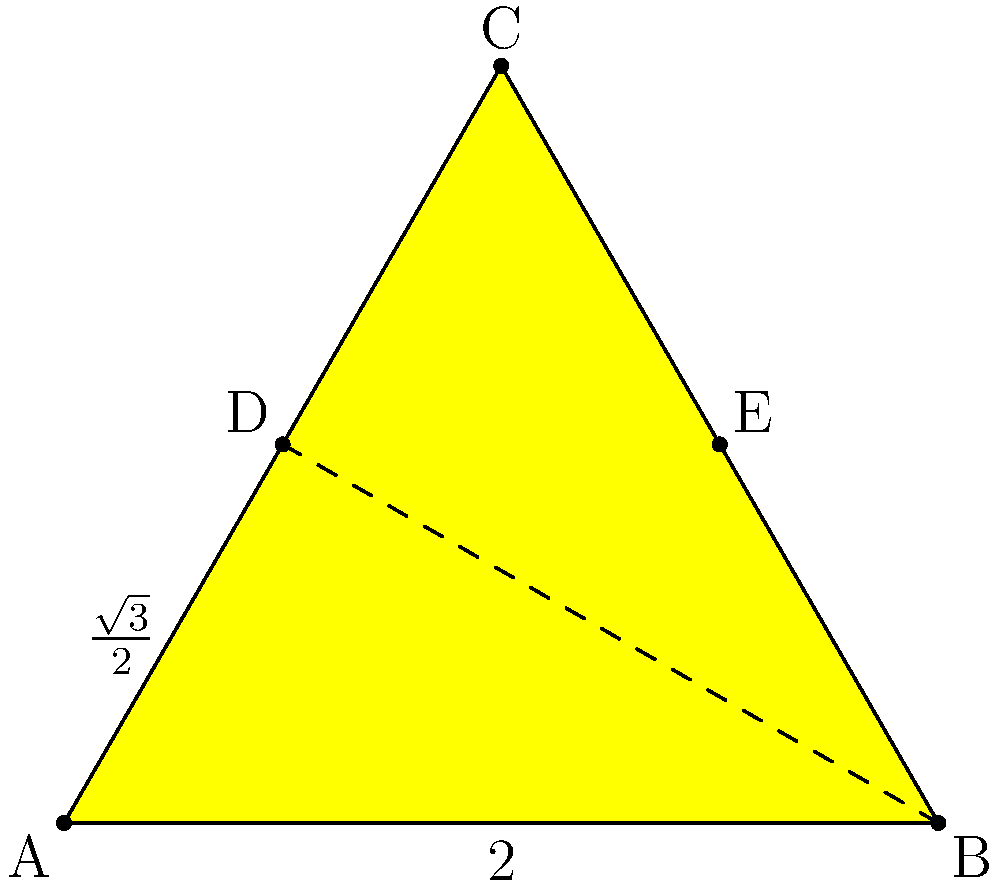You've been tasked with designing a star-shaped award plaque for a rising celebrity in your local community. The plaque is formed by a regular pentagon with a pentagram inside, as shown in the diagram. If the side length of the pentagon is 2 units, calculate the total area of the star-shaped plaque. Round your answer to two decimal places. Let's approach this step-by-step:

1) First, we need to calculate the area of the regular pentagon.
   - The pentagon can be divided into 5 equal triangles.
   - Each triangle has a base of 2 and a height of $\frac{\sqrt{3}}{2}$.
   - Area of one triangle = $\frac{1}{2} \times 2 \times \frac{\sqrt{3}}{2} = \frac{\sqrt{3}}{2}$
   - Area of pentagon = $5 \times \frac{\sqrt{3}}{2} = \frac{5\sqrt{3}}{2}$

2) Now, we need to find the area of the inner pentagram.
   - The pentagram consists of 5 equal triangles.
   - Each triangle has a base of 2 and a height of $\frac{\sqrt{3}}{6}$.
   - Area of one triangle = $\frac{1}{2} \times 2 \times \frac{\sqrt{3}}{6} = \frac{\sqrt{3}}{6}$
   - Area of pentagram = $5 \times \frac{\sqrt{3}}{6} = \frac{5\sqrt{3}}{6}$

3) The area of the star-shaped plaque is the difference between these two areas:
   $\text{Area}_{\text{star}} = \text{Area}_{\text{pentagon}} - \text{Area}_{\text{pentagram}}$
   $= \frac{5\sqrt{3}}{2} - \frac{5\sqrt{3}}{6}$
   $= \frac{15\sqrt{3}}{6} - \frac{5\sqrt{3}}{6}$
   $= \frac{10\sqrt{3}}{6}$
   $= \frac{5\sqrt{3}}{3}$

4) Converting to a decimal and rounding to two places:
   $\frac{5\sqrt{3}}{3} \approx 2.89$ square units
Answer: 2.89 square units 